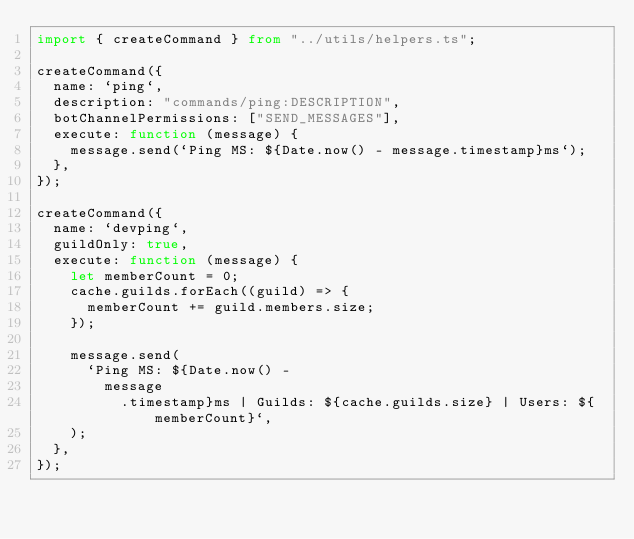<code> <loc_0><loc_0><loc_500><loc_500><_TypeScript_>import { createCommand } from "../utils/helpers.ts";

createCommand({
  name: `ping`,
  description: "commands/ping:DESCRIPTION",
  botChannelPermissions: ["SEND_MESSAGES"],
  execute: function (message) {
    message.send(`Ping MS: ${Date.now() - message.timestamp}ms`);
  },
});

createCommand({
  name: `devping`,
  guildOnly: true,
  execute: function (message) {
    let memberCount = 0;
    cache.guilds.forEach((guild) => {
      memberCount += guild.members.size;
    });

    message.send(
      `Ping MS: ${Date.now() -
        message
          .timestamp}ms | Guilds: ${cache.guilds.size} | Users: ${memberCount}`,
    );
  },
});
</code> 